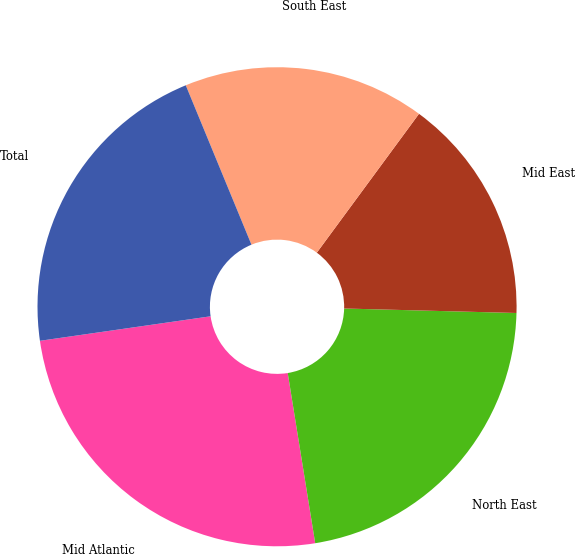Convert chart to OTSL. <chart><loc_0><loc_0><loc_500><loc_500><pie_chart><fcel>Mid Atlantic<fcel>North East<fcel>Mid East<fcel>South East<fcel>Total<nl><fcel>25.28%<fcel>22.04%<fcel>15.32%<fcel>16.32%<fcel>21.05%<nl></chart> 